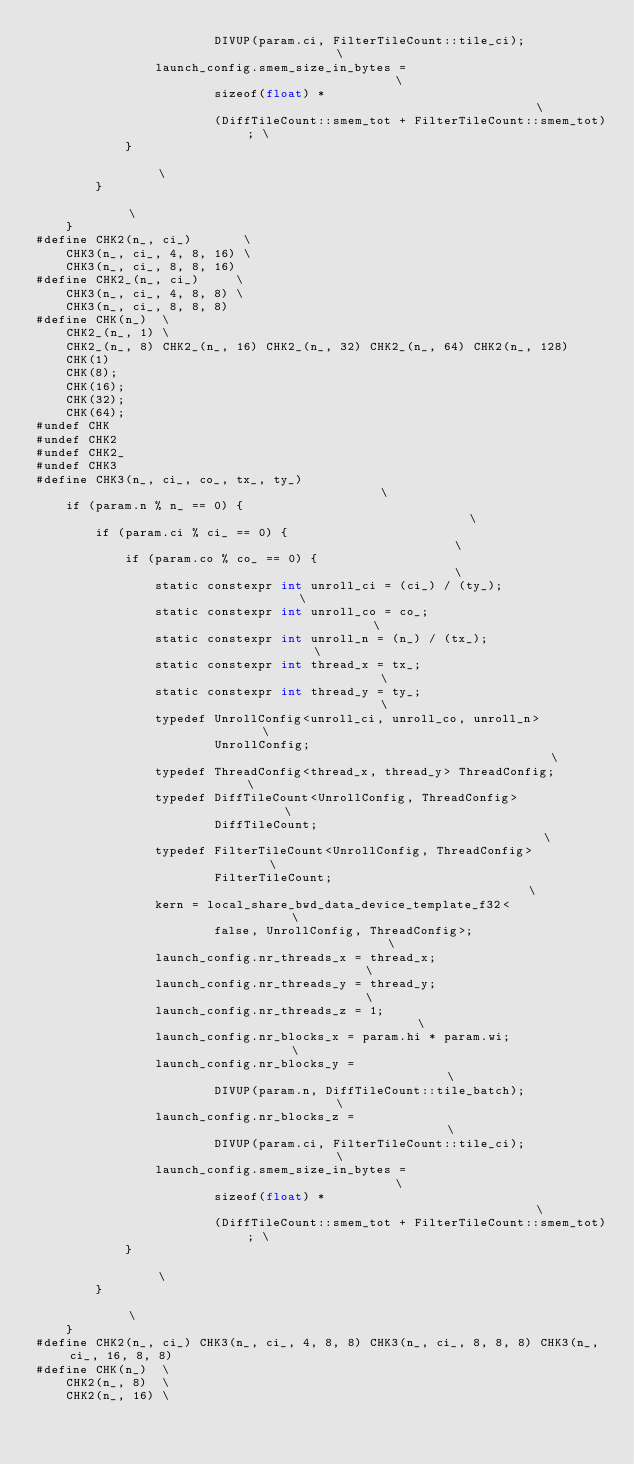<code> <loc_0><loc_0><loc_500><loc_500><_Cuda_>                        DIVUP(param.ci, FilterTileCount::tile_ci);             \
                launch_config.smem_size_in_bytes =                             \
                        sizeof(float) *                                        \
                        (DiffTileCount::smem_tot + FilterTileCount::smem_tot); \
            }                                                                  \
        }                                                                      \
    }
#define CHK2(n_, ci_)       \
    CHK3(n_, ci_, 4, 8, 16) \
    CHK3(n_, ci_, 8, 8, 16)
#define CHK2_(n_, ci_)     \
    CHK3(n_, ci_, 4, 8, 8) \
    CHK3(n_, ci_, 8, 8, 8)
#define CHK(n_)  \
    CHK2_(n_, 1) \
    CHK2_(n_, 8) CHK2_(n_, 16) CHK2_(n_, 32) CHK2_(n_, 64) CHK2(n_, 128)
    CHK(1)
    CHK(8);
    CHK(16);
    CHK(32);
    CHK(64);
#undef CHK
#undef CHK2
#undef CHK2_
#undef CHK3
#define CHK3(n_, ci_, co_, tx_, ty_)                                           \
    if (param.n % n_ == 0) {                                                   \
        if (param.ci % ci_ == 0) {                                             \
            if (param.co % co_ == 0) {                                         \
                static constexpr int unroll_ci = (ci_) / (ty_);                \
                static constexpr int unroll_co = co_;                          \
                static constexpr int unroll_n = (n_) / (tx_);                  \
                static constexpr int thread_x = tx_;                           \
                static constexpr int thread_y = ty_;                           \
                typedef UnrollConfig<unroll_ci, unroll_co, unroll_n>           \
                        UnrollConfig;                                          \
                typedef ThreadConfig<thread_x, thread_y> ThreadConfig;         \
                typedef DiffTileCount<UnrollConfig, ThreadConfig>              \
                        DiffTileCount;                                         \
                typedef FilterTileCount<UnrollConfig, ThreadConfig>            \
                        FilterTileCount;                                       \
                kern = local_share_bwd_data_device_template_f32<               \
                        false, UnrollConfig, ThreadConfig>;                    \
                launch_config.nr_threads_x = thread_x;                         \
                launch_config.nr_threads_y = thread_y;                         \
                launch_config.nr_threads_z = 1;                                \
                launch_config.nr_blocks_x = param.hi * param.wi;               \
                launch_config.nr_blocks_y =                                    \
                        DIVUP(param.n, DiffTileCount::tile_batch);             \
                launch_config.nr_blocks_z =                                    \
                        DIVUP(param.ci, FilterTileCount::tile_ci);             \
                launch_config.smem_size_in_bytes =                             \
                        sizeof(float) *                                        \
                        (DiffTileCount::smem_tot + FilterTileCount::smem_tot); \
            }                                                                  \
        }                                                                      \
    }
#define CHK2(n_, ci_) CHK3(n_, ci_, 4, 8, 8) CHK3(n_, ci_, 8, 8, 8) CHK3(n_, ci_, 16, 8, 8)
#define CHK(n_)  \
    CHK2(n_, 8)  \
    CHK2(n_, 16) \</code> 